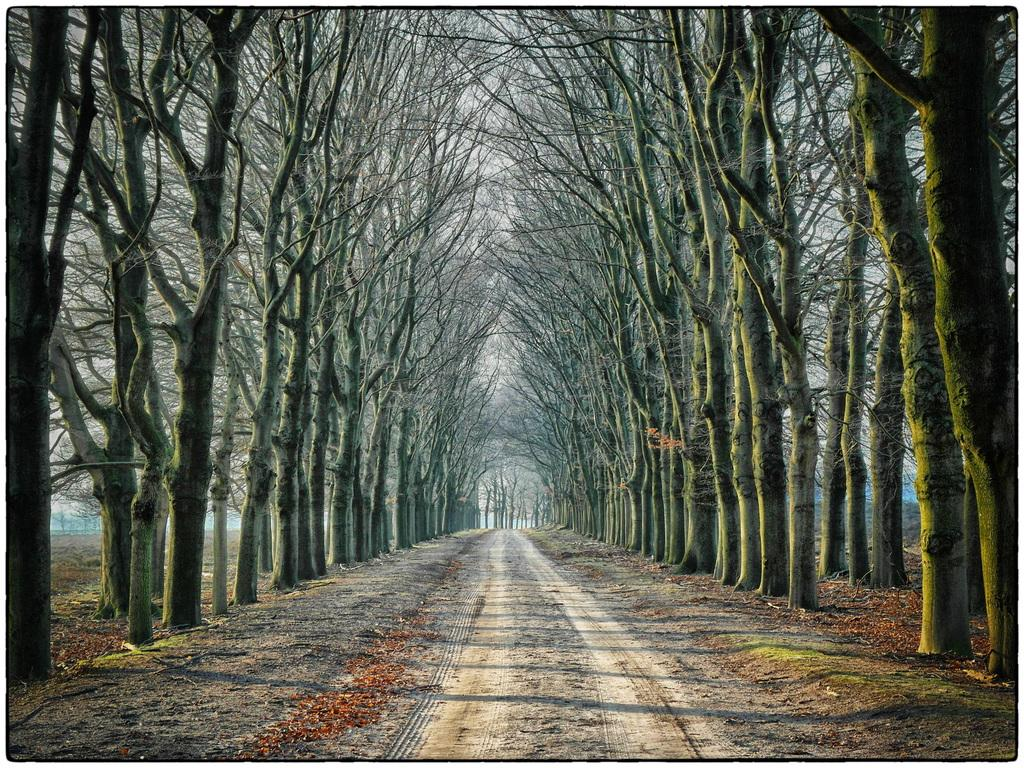What type of natural elements can be seen in the image? There are trees in the image. What man-made feature is present at the bottom of the image? There is a road at the bottom of the image. What title is given to the trees in the image? There is no title given to the trees in the image; they are simply trees. What direction should one take to reach the trees in the image? The image does not provide any information about directions or how to reach the trees. 